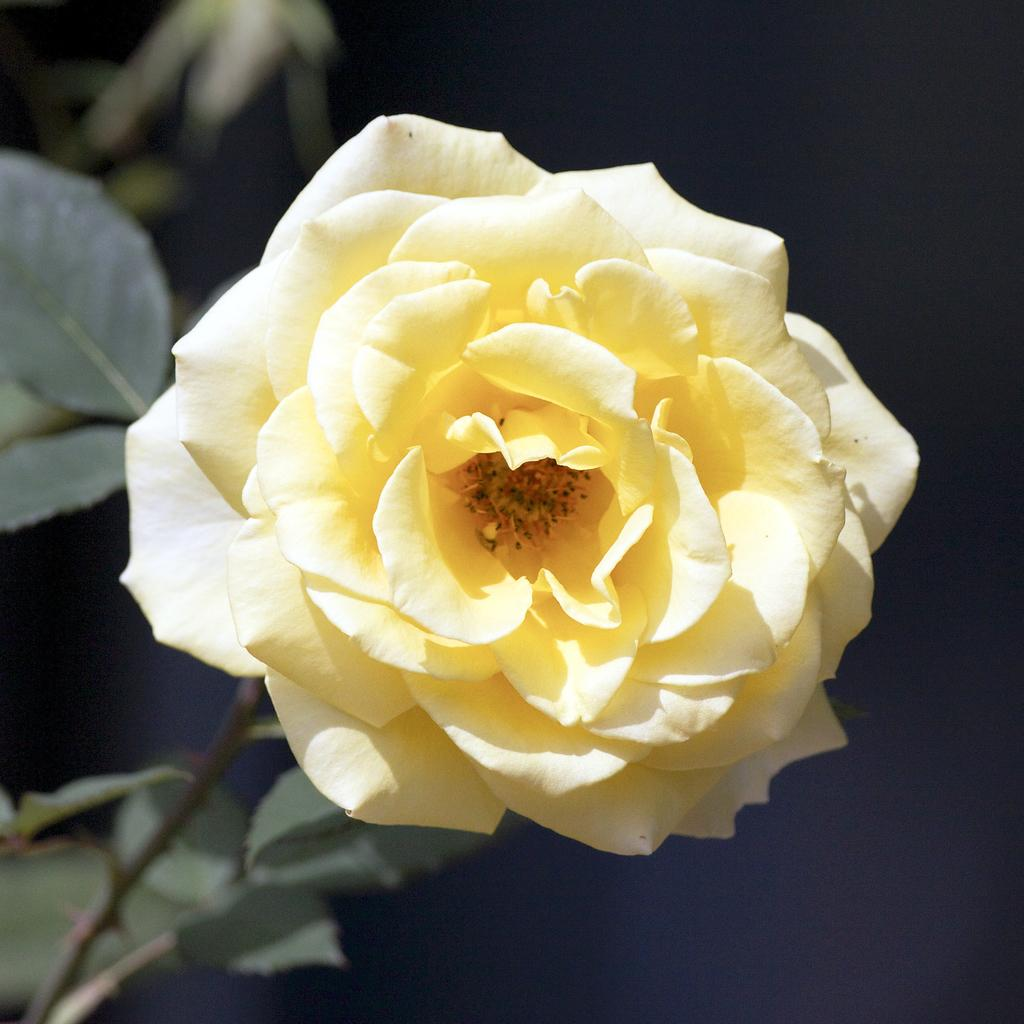What type of flower is in the picture? There is a yellow rose in the picture. What are the additional parts of the rose that can be seen? The rose has leaves and is attached to a stem. What is the color of the backdrop in the image? The backdrop of the image is dark. Can you see a twig being used for a game of basketball in the image? There is no twig or basketball present in the image. How is the yellow rose being transported in the image? The yellow rose is not being transported in the image; it is stationary in the picture. 